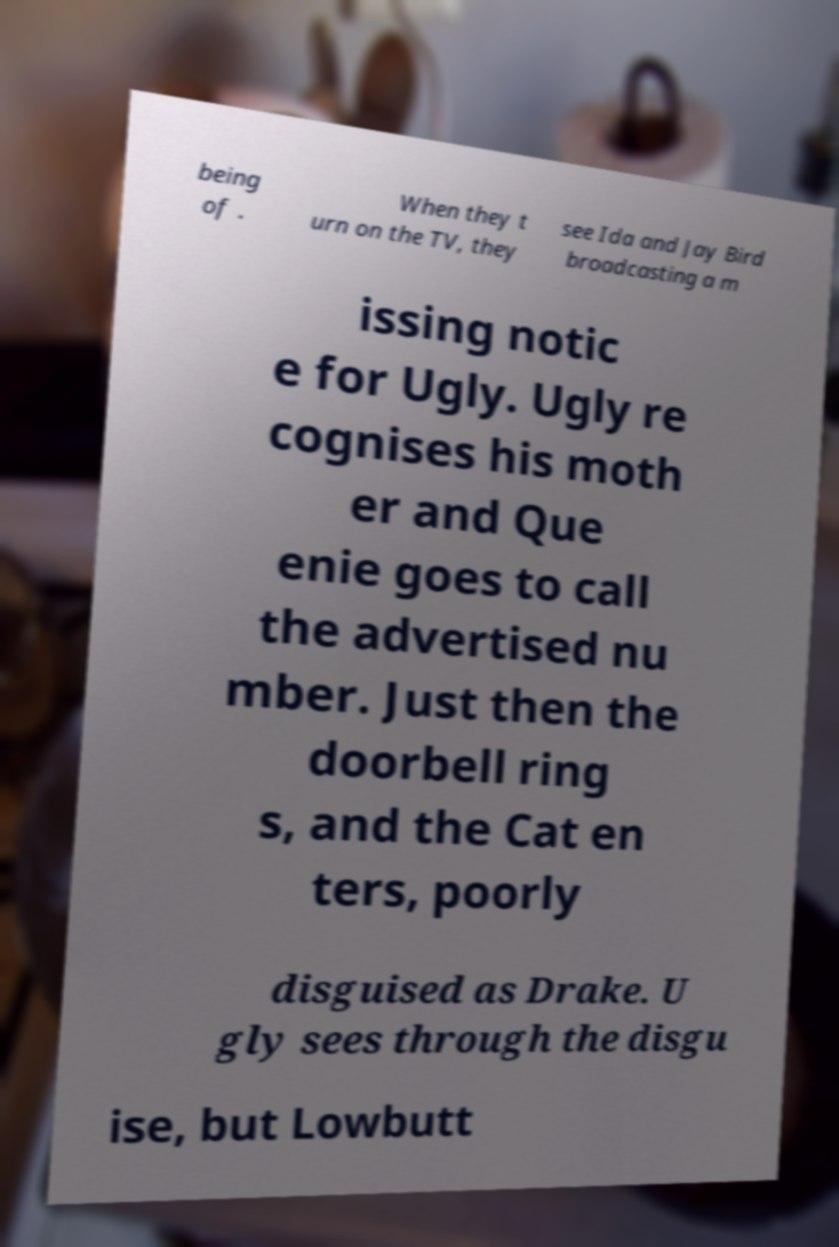Could you extract and type out the text from this image? being of . When they t urn on the TV, they see Ida and Jay Bird broadcasting a m issing notic e for Ugly. Ugly re cognises his moth er and Que enie goes to call the advertised nu mber. Just then the doorbell ring s, and the Cat en ters, poorly disguised as Drake. U gly sees through the disgu ise, but Lowbutt 